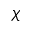<formula> <loc_0><loc_0><loc_500><loc_500>\chi</formula> 